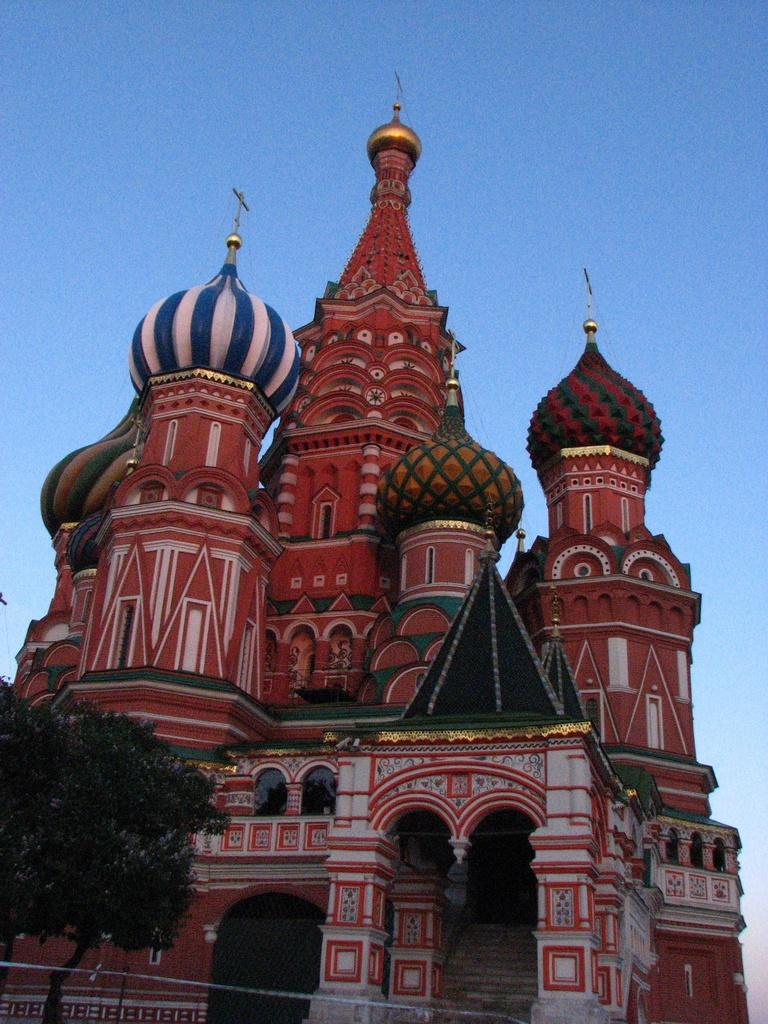What type of structure is in the image? There is a castle in the image. Where is the tree located in the image? The tree is in the bottom left of the image. What is visible at the top of the image? The sky is visible at the top of the image. Can you see a snake slithering around the castle in the image? There is no snake present in the image. Is there a table with food and drinks set up near the castle in the image? There is no table with food and drinks visible in the image. 